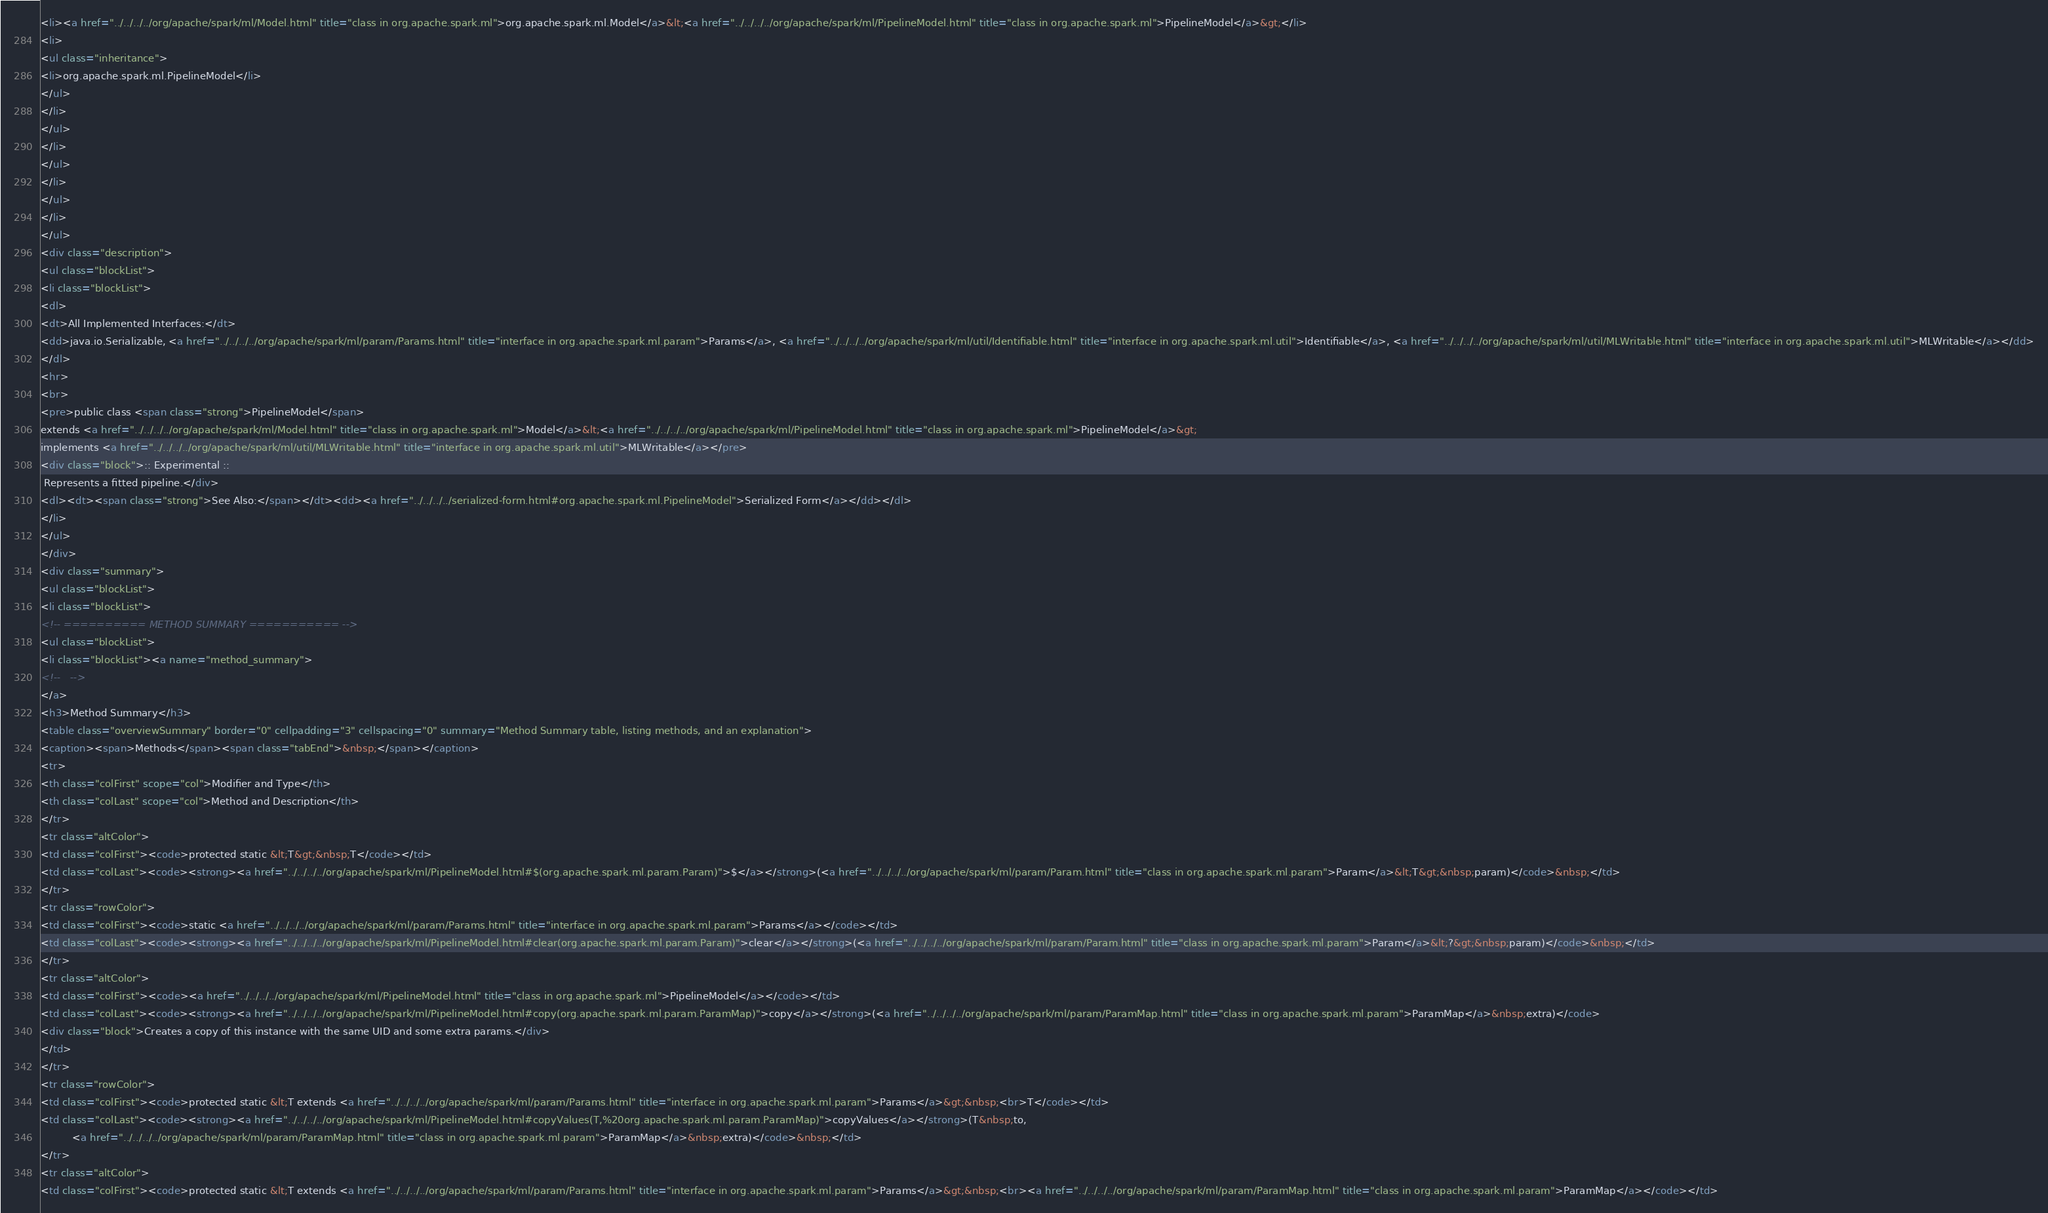<code> <loc_0><loc_0><loc_500><loc_500><_HTML_><li><a href="../../../../org/apache/spark/ml/Model.html" title="class in org.apache.spark.ml">org.apache.spark.ml.Model</a>&lt;<a href="../../../../org/apache/spark/ml/PipelineModel.html" title="class in org.apache.spark.ml">PipelineModel</a>&gt;</li>
<li>
<ul class="inheritance">
<li>org.apache.spark.ml.PipelineModel</li>
</ul>
</li>
</ul>
</li>
</ul>
</li>
</ul>
</li>
</ul>
<div class="description">
<ul class="blockList">
<li class="blockList">
<dl>
<dt>All Implemented Interfaces:</dt>
<dd>java.io.Serializable, <a href="../../../../org/apache/spark/ml/param/Params.html" title="interface in org.apache.spark.ml.param">Params</a>, <a href="../../../../org/apache/spark/ml/util/Identifiable.html" title="interface in org.apache.spark.ml.util">Identifiable</a>, <a href="../../../../org/apache/spark/ml/util/MLWritable.html" title="interface in org.apache.spark.ml.util">MLWritable</a></dd>
</dl>
<hr>
<br>
<pre>public class <span class="strong">PipelineModel</span>
extends <a href="../../../../org/apache/spark/ml/Model.html" title="class in org.apache.spark.ml">Model</a>&lt;<a href="../../../../org/apache/spark/ml/PipelineModel.html" title="class in org.apache.spark.ml">PipelineModel</a>&gt;
implements <a href="../../../../org/apache/spark/ml/util/MLWritable.html" title="interface in org.apache.spark.ml.util">MLWritable</a></pre>
<div class="block">:: Experimental ::
 Represents a fitted pipeline.</div>
<dl><dt><span class="strong">See Also:</span></dt><dd><a href="../../../../serialized-form.html#org.apache.spark.ml.PipelineModel">Serialized Form</a></dd></dl>
</li>
</ul>
</div>
<div class="summary">
<ul class="blockList">
<li class="blockList">
<!-- ========== METHOD SUMMARY =========== -->
<ul class="blockList">
<li class="blockList"><a name="method_summary">
<!--   -->
</a>
<h3>Method Summary</h3>
<table class="overviewSummary" border="0" cellpadding="3" cellspacing="0" summary="Method Summary table, listing methods, and an explanation">
<caption><span>Methods</span><span class="tabEnd">&nbsp;</span></caption>
<tr>
<th class="colFirst" scope="col">Modifier and Type</th>
<th class="colLast" scope="col">Method and Description</th>
</tr>
<tr class="altColor">
<td class="colFirst"><code>protected static &lt;T&gt;&nbsp;T</code></td>
<td class="colLast"><code><strong><a href="../../../../org/apache/spark/ml/PipelineModel.html#$(org.apache.spark.ml.param.Param)">$</a></strong>(<a href="../../../../org/apache/spark/ml/param/Param.html" title="class in org.apache.spark.ml.param">Param</a>&lt;T&gt;&nbsp;param)</code>&nbsp;</td>
</tr>
<tr class="rowColor">
<td class="colFirst"><code>static <a href="../../../../org/apache/spark/ml/param/Params.html" title="interface in org.apache.spark.ml.param">Params</a></code></td>
<td class="colLast"><code><strong><a href="../../../../org/apache/spark/ml/PipelineModel.html#clear(org.apache.spark.ml.param.Param)">clear</a></strong>(<a href="../../../../org/apache/spark/ml/param/Param.html" title="class in org.apache.spark.ml.param">Param</a>&lt;?&gt;&nbsp;param)</code>&nbsp;</td>
</tr>
<tr class="altColor">
<td class="colFirst"><code><a href="../../../../org/apache/spark/ml/PipelineModel.html" title="class in org.apache.spark.ml">PipelineModel</a></code></td>
<td class="colLast"><code><strong><a href="../../../../org/apache/spark/ml/PipelineModel.html#copy(org.apache.spark.ml.param.ParamMap)">copy</a></strong>(<a href="../../../../org/apache/spark/ml/param/ParamMap.html" title="class in org.apache.spark.ml.param">ParamMap</a>&nbsp;extra)</code>
<div class="block">Creates a copy of this instance with the same UID and some extra params.</div>
</td>
</tr>
<tr class="rowColor">
<td class="colFirst"><code>protected static &lt;T extends <a href="../../../../org/apache/spark/ml/param/Params.html" title="interface in org.apache.spark.ml.param">Params</a>&gt;&nbsp;<br>T</code></td>
<td class="colLast"><code><strong><a href="../../../../org/apache/spark/ml/PipelineModel.html#copyValues(T,%20org.apache.spark.ml.param.ParamMap)">copyValues</a></strong>(T&nbsp;to,
          <a href="../../../../org/apache/spark/ml/param/ParamMap.html" title="class in org.apache.spark.ml.param">ParamMap</a>&nbsp;extra)</code>&nbsp;</td>
</tr>
<tr class="altColor">
<td class="colFirst"><code>protected static &lt;T extends <a href="../../../../org/apache/spark/ml/param/Params.html" title="interface in org.apache.spark.ml.param">Params</a>&gt;&nbsp;<br><a href="../../../../org/apache/spark/ml/param/ParamMap.html" title="class in org.apache.spark.ml.param">ParamMap</a></code></td></code> 